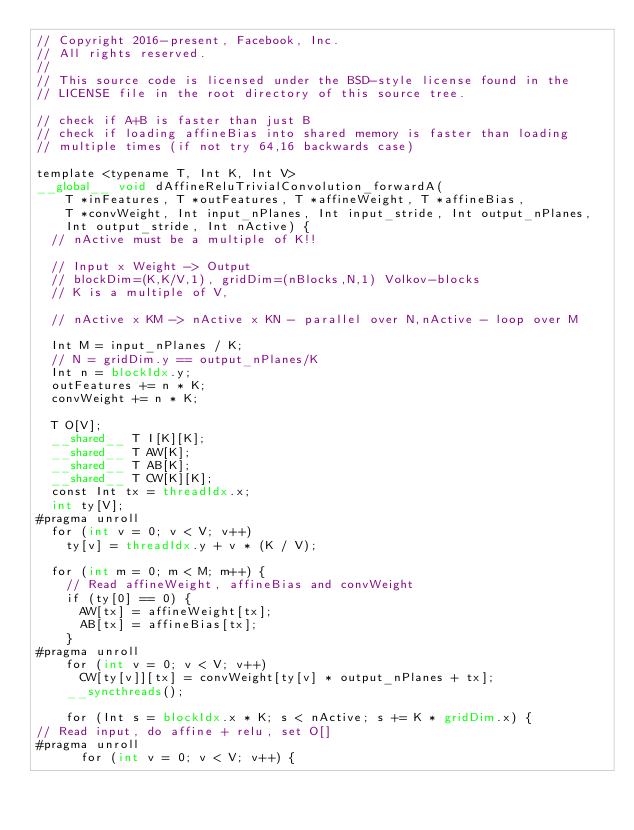<code> <loc_0><loc_0><loc_500><loc_500><_Cuda_>// Copyright 2016-present, Facebook, Inc.
// All rights reserved.
//
// This source code is licensed under the BSD-style license found in the
// LICENSE file in the root directory of this source tree.

// check if A+B is faster than just B
// check if loading affineBias into shared memory is faster than loading
// multiple times (if not try 64,16 backwards case)

template <typename T, Int K, Int V>
__global__ void dAffineReluTrivialConvolution_forwardA(
    T *inFeatures, T *outFeatures, T *affineWeight, T *affineBias,
    T *convWeight, Int input_nPlanes, Int input_stride, Int output_nPlanes,
    Int output_stride, Int nActive) {
  // nActive must be a multiple of K!!

  // Input x Weight -> Output
  // blockDim=(K,K/V,1), gridDim=(nBlocks,N,1) Volkov-blocks
  // K is a multiple of V,

  // nActive x KM -> nActive x KN - parallel over N,nActive - loop over M

  Int M = input_nPlanes / K;
  // N = gridDim.y == output_nPlanes/K
  Int n = blockIdx.y;
  outFeatures += n * K;
  convWeight += n * K;

  T O[V];
  __shared__ T I[K][K];
  __shared__ T AW[K];
  __shared__ T AB[K];
  __shared__ T CW[K][K];
  const Int tx = threadIdx.x;
  int ty[V];
#pragma unroll
  for (int v = 0; v < V; v++)
    ty[v] = threadIdx.y + v * (K / V);

  for (int m = 0; m < M; m++) {
    // Read affineWeight, affineBias and convWeight
    if (ty[0] == 0) {
      AW[tx] = affineWeight[tx];
      AB[tx] = affineBias[tx];
    }
#pragma unroll
    for (int v = 0; v < V; v++)
      CW[ty[v]][tx] = convWeight[ty[v] * output_nPlanes + tx];
    __syncthreads();

    for (Int s = blockIdx.x * K; s < nActive; s += K * gridDim.x) {
// Read input, do affine + relu, set O[]
#pragma unroll
      for (int v = 0; v < V; v++) {</code> 